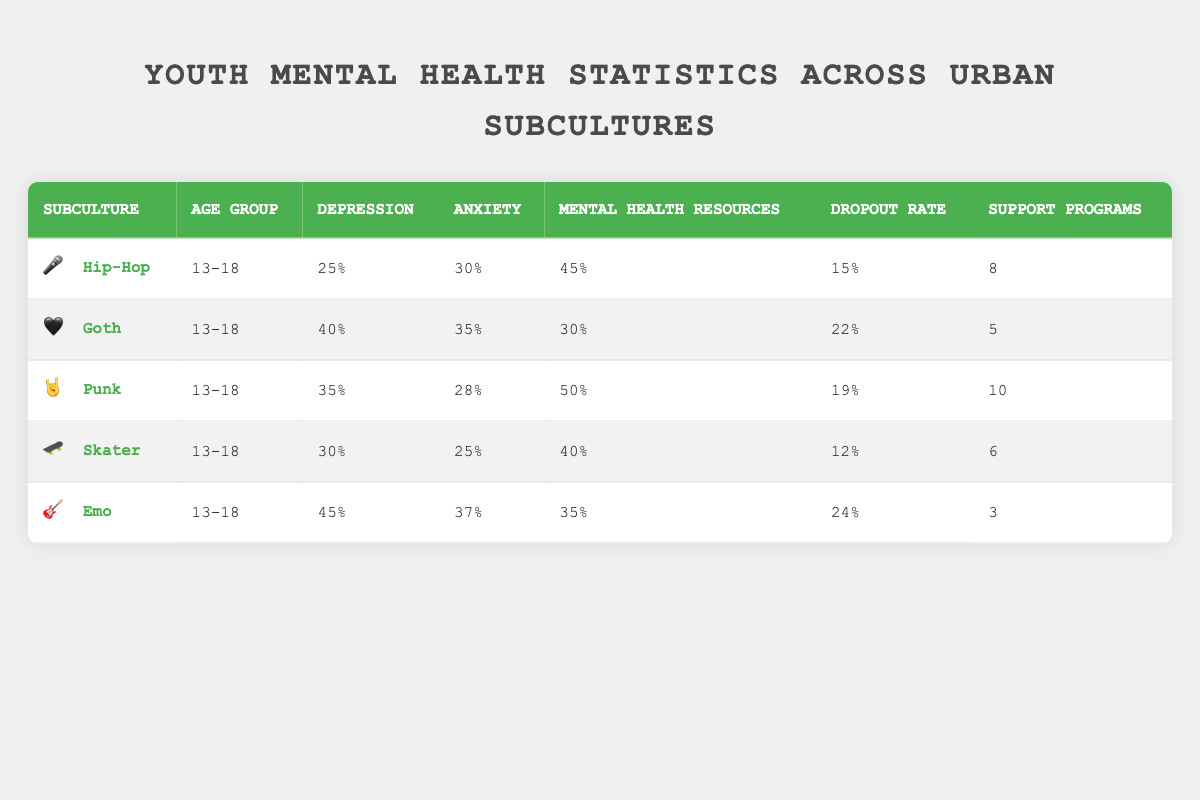What is the prevalence of anxiety among Emo youth? The table lists the prevalence of anxiety for the Emo subculture under the Anxiety column, which indicates it is 37%.
Answer: 37% How many Community Support Programs are available for the Punk subculture? According to the table, the Punk subculture has 10 Community Support Programs listed in the respective column.
Answer: 10 Which subculture has the highest School Dropout Rate? By comparing the School Dropout Rates across all subcultures, Emo has the highest rate at 24%.
Answer: Emo What is the average prevalence of depression across all listed urban subcultures? The prevalence of depression for each subculture is 25%, 40%, 35%, 30%, and 45%. The sum of these values is 175%, and dividing this by the number of subcultures (5) gives an average prevalence of 35%.
Answer: 35% Is it true that Skater youth have more access to mental health resources than Goth youth? By comparing the Access to Mental Health Resources column, Skater has 40% access while Goth has only 30%. Therefore, it is true that Skater youth have more access than Goth youth.
Answer: Yes Which subculture has the lowest prevalence of depression? Looking at the Prevalence of Depression column, the Hip-Hop subculture has the lowest percentage at 25%.
Answer: Hip-Hop What is the difference in the prevalence of anxiety between Emo and Punk youth? The prevalence of anxiety for Emo is 37% and for Punk is 28%. The difference is calculated as 37% - 28% = 9%.
Answer: 9% How many urban subcultures have a School Dropout Rate of 20% or more? From the table, the Goth (22% dropout), Emo (24% dropout), and Punk (19% dropout) subcultures can be analyzed. Goth and Emo both have a dropout rate of 20% or more, which makes it 2 subcultures fitting this criterion.
Answer: 2 Which urban subculture combines the highest rates of both depression and anxiety? By examining the data for the depression and anxiety percentages, Emo has the highest rates with 45% depression and 37% anxiety, totaling 82%. Other subcultures have lower combinations.
Answer: Emo 